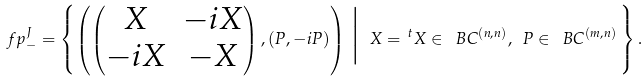<formula> <loc_0><loc_0><loc_500><loc_500>\ f p _ { - } ^ { J } = \left \{ \left ( \begin{pmatrix} X & - i X \\ - i X & - X \end{pmatrix} , ( P , - i P ) \right ) \, \Big | \ X = \, ^ { t } X \in \ B C ^ { ( n , n ) } , \ P \in \ B C ^ { ( m , n ) } \, \right \} .</formula> 